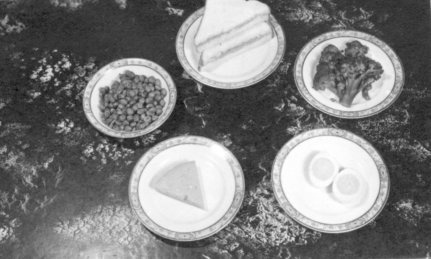Describe the objects in this image and their specific colors. I can see dining table in gray, black, lightgray, and darkgray tones, bowl in gray, white, darkgray, and black tones, bowl in gray, lightgray, darkgray, and black tones, bowl in gray, darkgray, lightgray, and black tones, and cake in gray, lightgray, darkgray, and black tones in this image. 